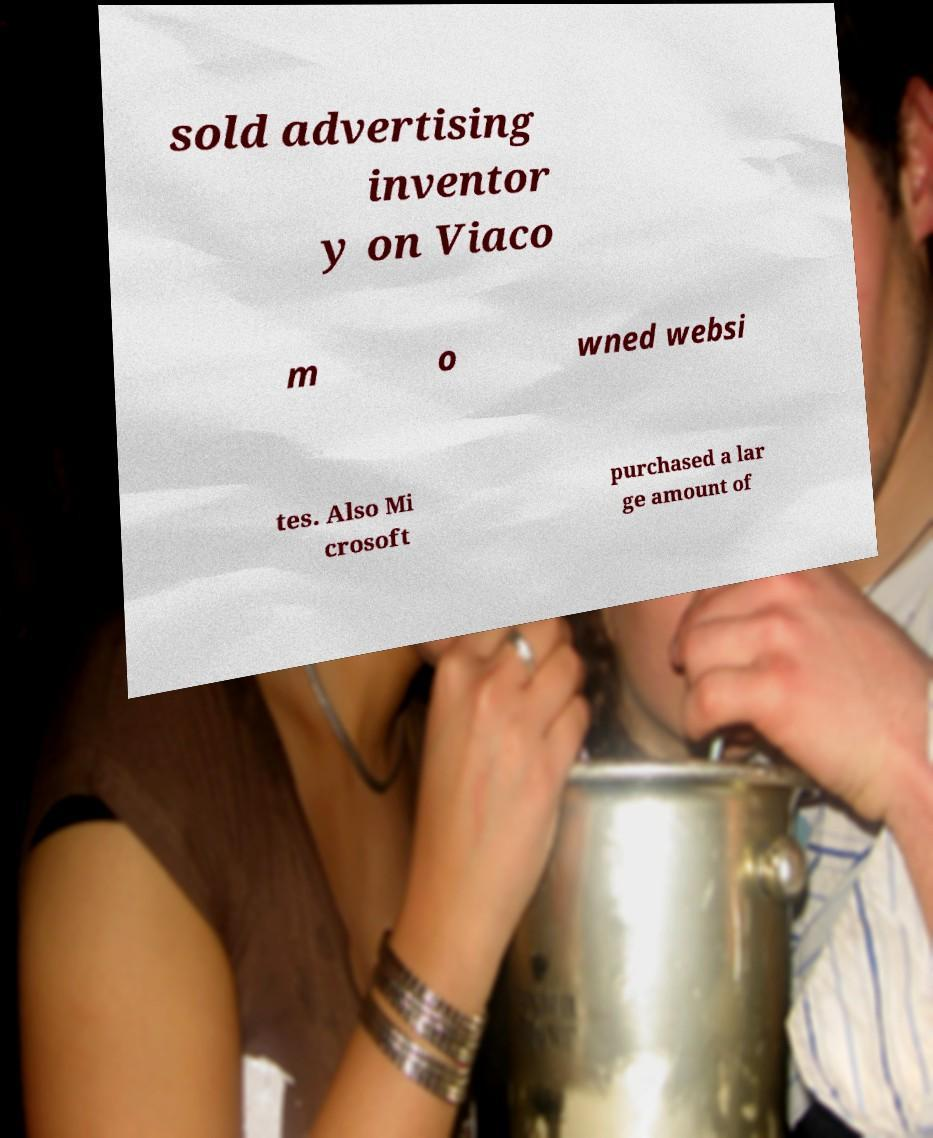Please read and relay the text visible in this image. What does it say? sold advertising inventor y on Viaco m o wned websi tes. Also Mi crosoft purchased a lar ge amount of 